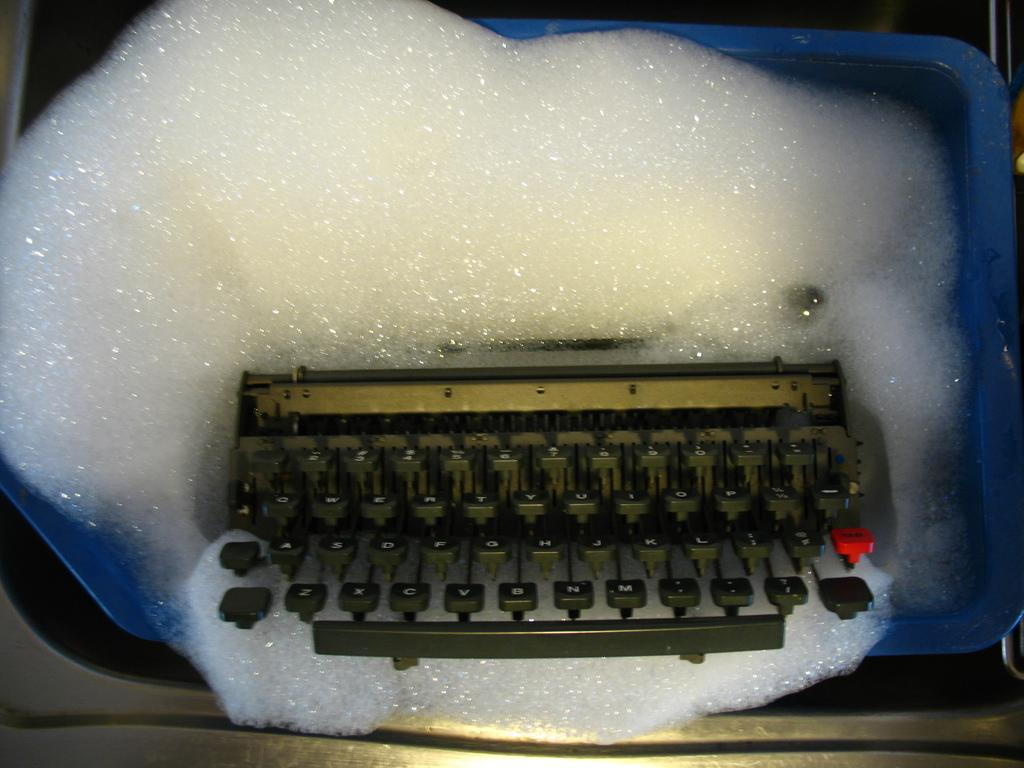Provide a one-sentence caption for the provided image. An old typewriter with one red key that is three keys right of the L key. 